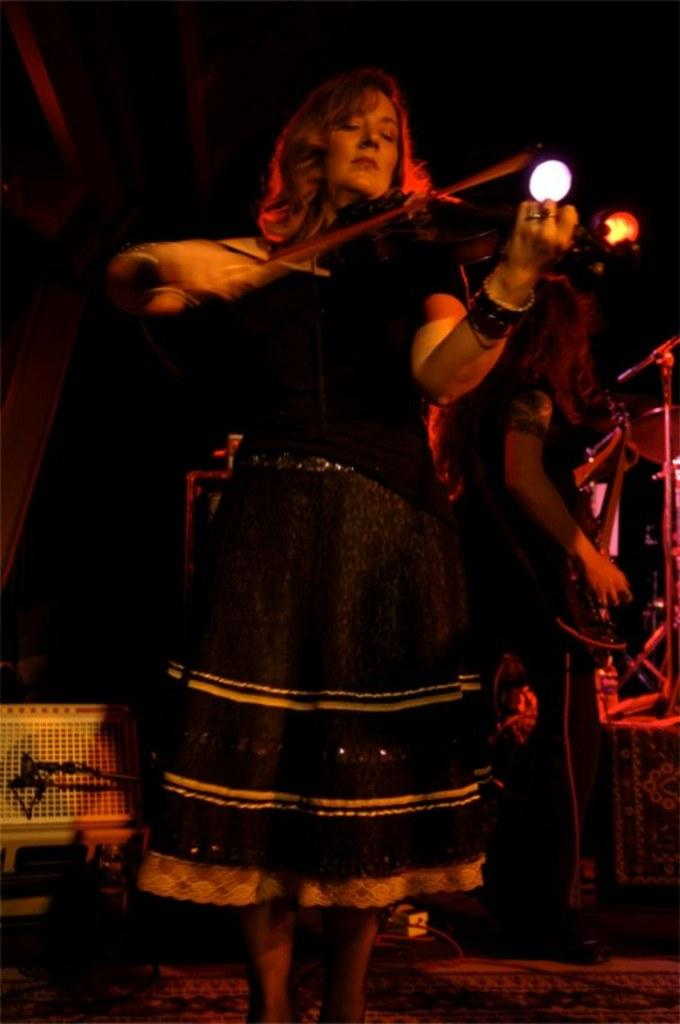What is the main subject in the foreground of the image? There is a woman playing a violin in the foreground of the image. What is the other woman holding in the image? The other woman is holding a guitar in the image. How would you describe the lighting in the image? The background of the image is dark. Can you make out any details about the objects in the dark background? No, the objects in the dark background are not clear. What type of oil is being used by the woman playing the violin in the image? There is no indication in the image that any oil is being used by the woman playing the violin. 